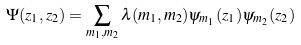Convert formula to latex. <formula><loc_0><loc_0><loc_500><loc_500>\Psi ( z _ { 1 } , z _ { 2 } ) = \sum _ { m _ { 1 } , m _ { 2 } } \lambda ( m _ { 1 } , m _ { 2 } ) \psi _ { m _ { 1 } } ( z _ { 1 } ) \psi _ { m _ { 2 } } ( z _ { 2 } )</formula> 